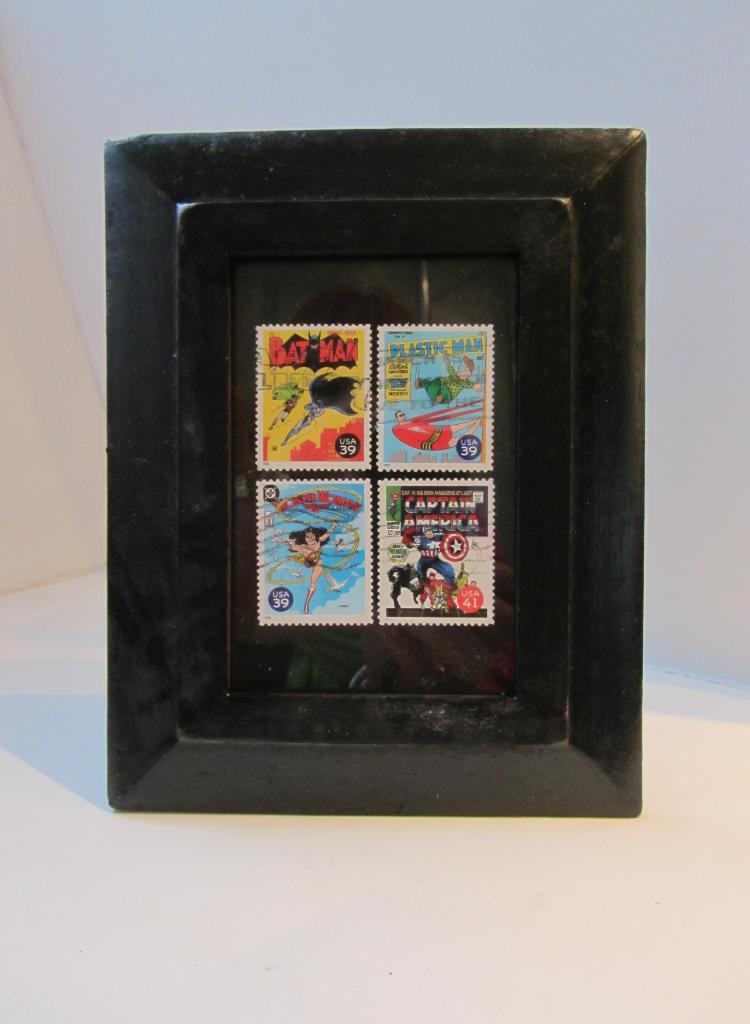How many stamps can you see?
Your answer should be very brief. Answering does not require reading text in the image. Does the top left one say "bat man?"?
Offer a terse response. Yes. 